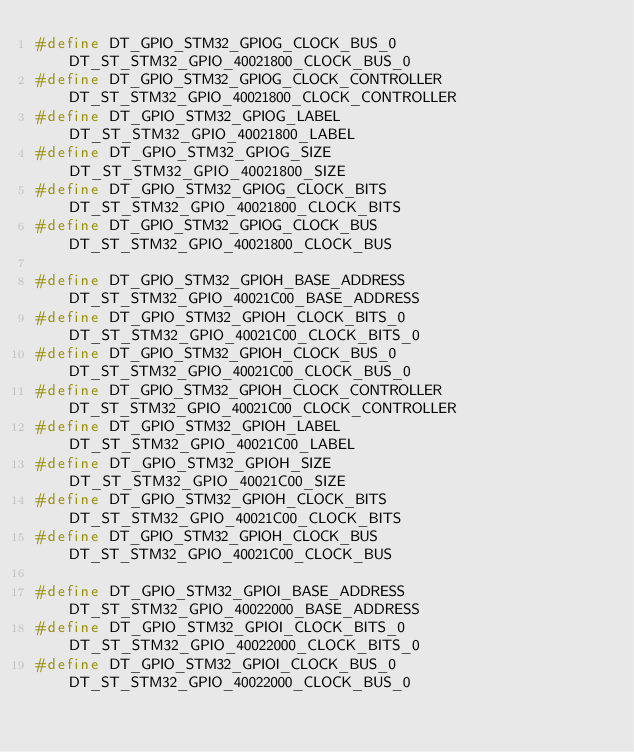<code> <loc_0><loc_0><loc_500><loc_500><_C_>#define DT_GPIO_STM32_GPIOG_CLOCK_BUS_0		DT_ST_STM32_GPIO_40021800_CLOCK_BUS_0
#define DT_GPIO_STM32_GPIOG_CLOCK_CONTROLLER	DT_ST_STM32_GPIO_40021800_CLOCK_CONTROLLER
#define DT_GPIO_STM32_GPIOG_LABEL			DT_ST_STM32_GPIO_40021800_LABEL
#define DT_GPIO_STM32_GPIOG_SIZE			DT_ST_STM32_GPIO_40021800_SIZE
#define DT_GPIO_STM32_GPIOG_CLOCK_BITS		DT_ST_STM32_GPIO_40021800_CLOCK_BITS
#define DT_GPIO_STM32_GPIOG_CLOCK_BUS		DT_ST_STM32_GPIO_40021800_CLOCK_BUS

#define DT_GPIO_STM32_GPIOH_BASE_ADDRESS		DT_ST_STM32_GPIO_40021C00_BASE_ADDRESS
#define DT_GPIO_STM32_GPIOH_CLOCK_BITS_0		DT_ST_STM32_GPIO_40021C00_CLOCK_BITS_0
#define DT_GPIO_STM32_GPIOH_CLOCK_BUS_0		DT_ST_STM32_GPIO_40021C00_CLOCK_BUS_0
#define DT_GPIO_STM32_GPIOH_CLOCK_CONTROLLER	DT_ST_STM32_GPIO_40021C00_CLOCK_CONTROLLER
#define DT_GPIO_STM32_GPIOH_LABEL			DT_ST_STM32_GPIO_40021C00_LABEL
#define DT_GPIO_STM32_GPIOH_SIZE			DT_ST_STM32_GPIO_40021C00_SIZE
#define DT_GPIO_STM32_GPIOH_CLOCK_BITS		DT_ST_STM32_GPIO_40021C00_CLOCK_BITS
#define DT_GPIO_STM32_GPIOH_CLOCK_BUS		DT_ST_STM32_GPIO_40021C00_CLOCK_BUS

#define DT_GPIO_STM32_GPIOI_BASE_ADDRESS		DT_ST_STM32_GPIO_40022000_BASE_ADDRESS
#define DT_GPIO_STM32_GPIOI_CLOCK_BITS_0		DT_ST_STM32_GPIO_40022000_CLOCK_BITS_0
#define DT_GPIO_STM32_GPIOI_CLOCK_BUS_0		DT_ST_STM32_GPIO_40022000_CLOCK_BUS_0</code> 